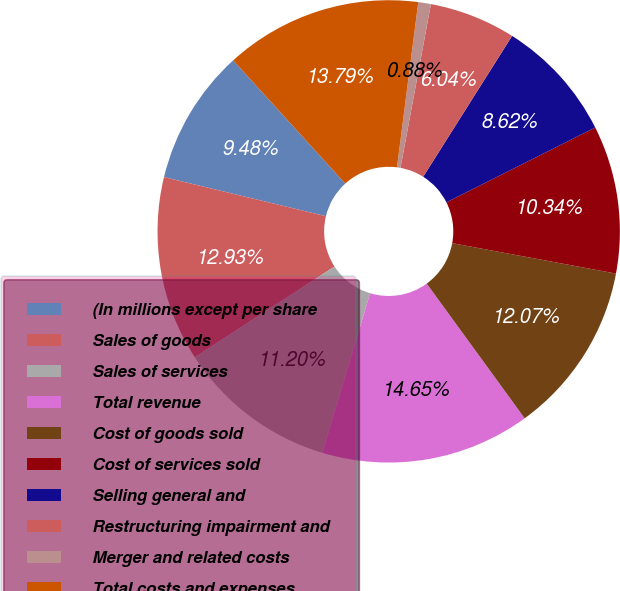<chart> <loc_0><loc_0><loc_500><loc_500><pie_chart><fcel>(In millions except per share<fcel>Sales of goods<fcel>Sales of services<fcel>Total revenue<fcel>Cost of goods sold<fcel>Cost of services sold<fcel>Selling general and<fcel>Restructuring impairment and<fcel>Merger and related costs<fcel>Total costs and expenses<nl><fcel>9.48%<fcel>12.93%<fcel>11.2%<fcel>14.65%<fcel>12.07%<fcel>10.34%<fcel>8.62%<fcel>6.04%<fcel>0.88%<fcel>13.79%<nl></chart> 